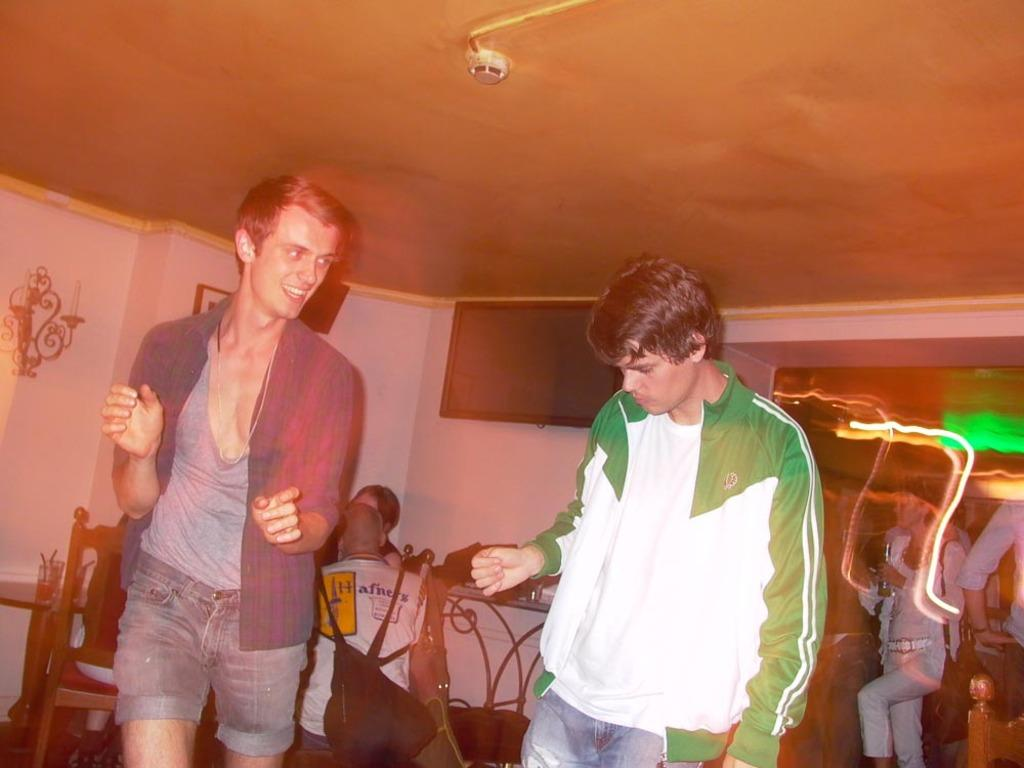Who or what can be seen in the image? There are people in the image. What type of furniture is present in the image? There are chairs and a table in the image. Can you describe any other objects in the image? There are unspecified "things" in the image. What is on the wall in the image? There is a picture and a decorative object on the wall. Is there any electronic device in the image? Yes, there is a television on the wall. What type of voyage is being planned by the cabbage in the image? There is no cabbage present in the image, and therefore no voyage can be planned by it. What role does the governor play in the image? There is no governor present in the image, and therefore no role can be assigned to it. 